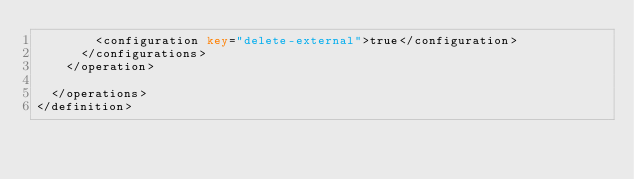Convert code to text. <code><loc_0><loc_0><loc_500><loc_500><_XML_>        <configuration key="delete-external">true</configuration>
      </configurations>
    </operation>

  </operations>
</definition>
</code> 